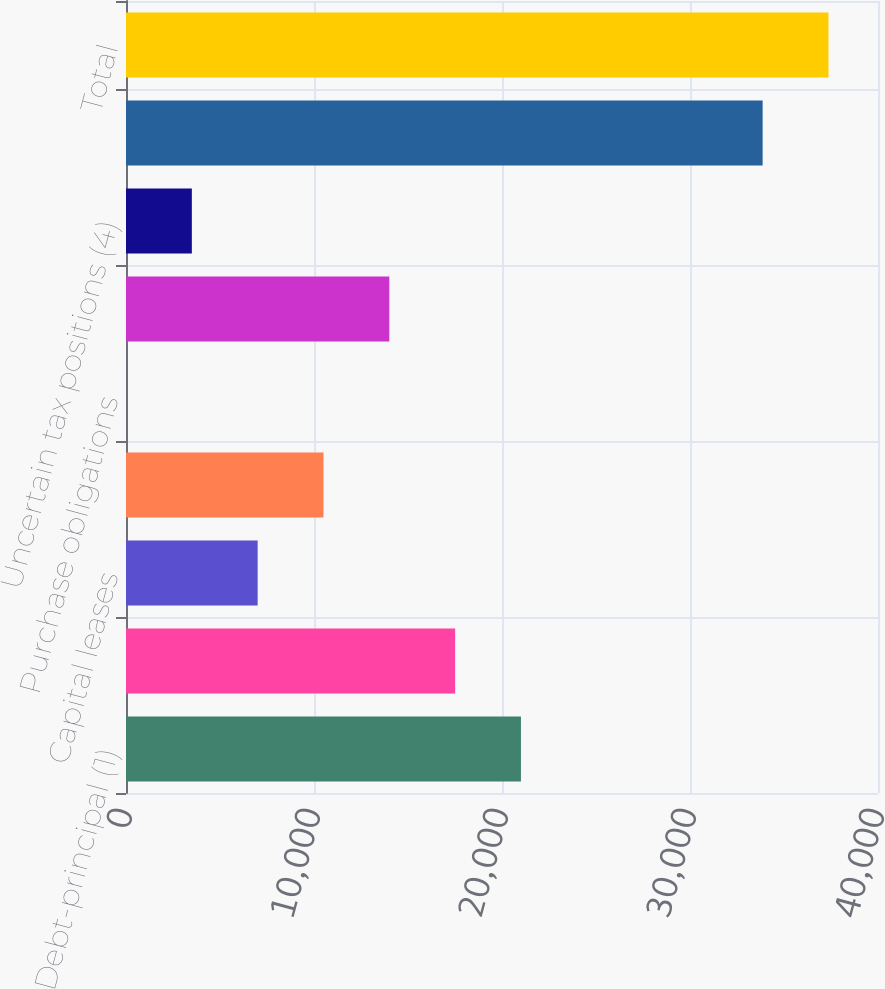Convert chart. <chart><loc_0><loc_0><loc_500><loc_500><bar_chart><fcel>Debt-principal (1)<fcel>Debt-interest (2)<fcel>Capital leases<fcel>Operating leases<fcel>Purchase obligations<fcel>Pension obligations (3)<fcel>Uncertain tax positions (4)<fcel>Future insurance obligations<fcel>Total<nl><fcel>21008.1<fcel>17506.9<fcel>7003.17<fcel>10504.4<fcel>0.71<fcel>14005.6<fcel>3501.94<fcel>33864<fcel>37365.2<nl></chart> 